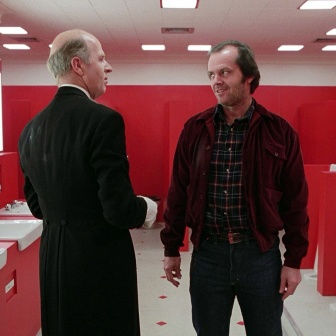Can you describe the expressions and possible emotions of the men in the image? Certainly! The man on the left appears to be calm and composed, possibly engaged in a serious conversation. His demeanor suggests he is either explaining something important or giving instructions. On the other hand, the man on the right has a somewhat amused or slightly surprised expression, indicated by his raised eyebrows and a slight smile. His relaxed stance suggests he is either listening attentively or reacting to something unexpected that the other man has said. 